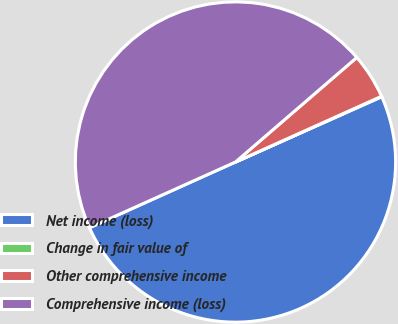<chart> <loc_0><loc_0><loc_500><loc_500><pie_chart><fcel>Net income (loss)<fcel>Change in fair value of<fcel>Other comprehensive income<fcel>Comprehensive income (loss)<nl><fcel>49.95%<fcel>0.05%<fcel>4.59%<fcel>45.41%<nl></chart> 